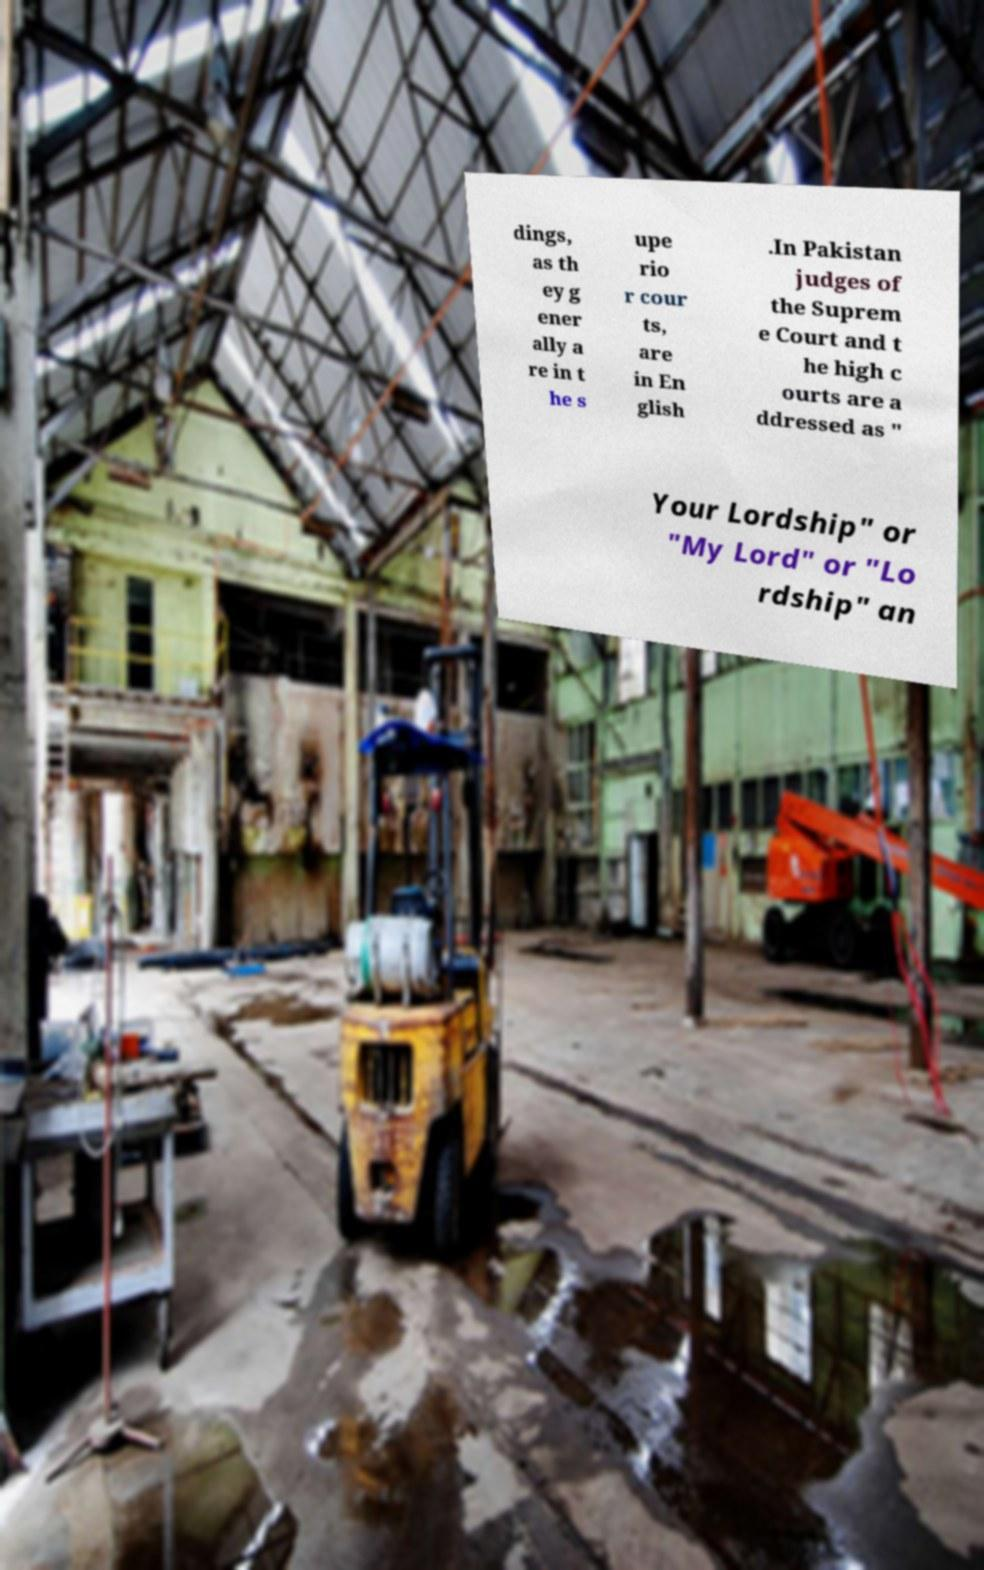Can you read and provide the text displayed in the image?This photo seems to have some interesting text. Can you extract and type it out for me? dings, as th ey g ener ally a re in t he s upe rio r cour ts, are in En glish .In Pakistan judges of the Suprem e Court and t he high c ourts are a ddressed as " Your Lordship" or "My Lord" or "Lo rdship" an 